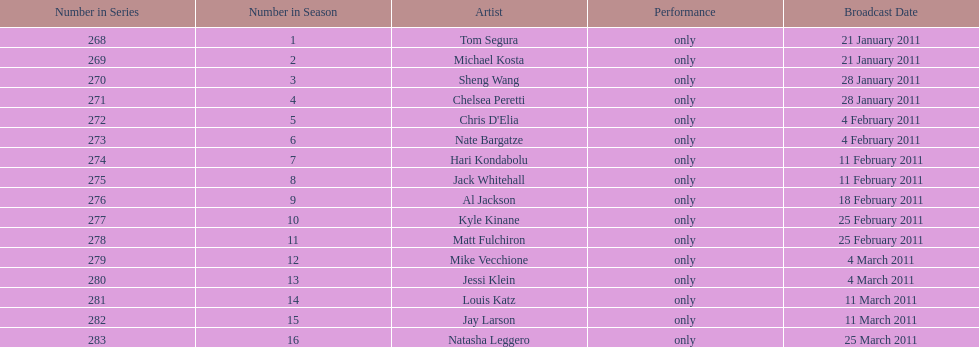What was hari's last name? Kondabolu. 